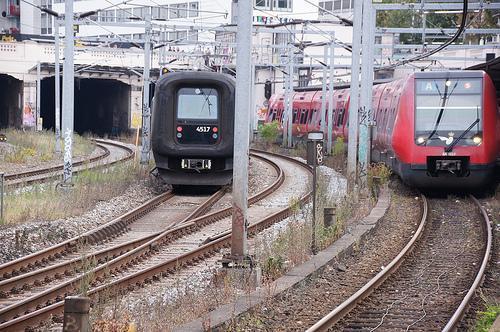How many trains are there?
Give a very brief answer. 2. How many kangaroos are in the image?
Give a very brief answer. 0. 